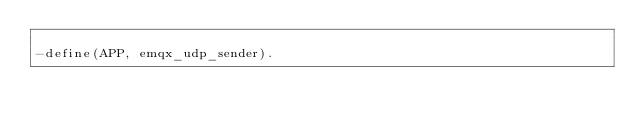Convert code to text. <code><loc_0><loc_0><loc_500><loc_500><_Erlang_>
-define(APP, emqx_udp_sender).
</code> 